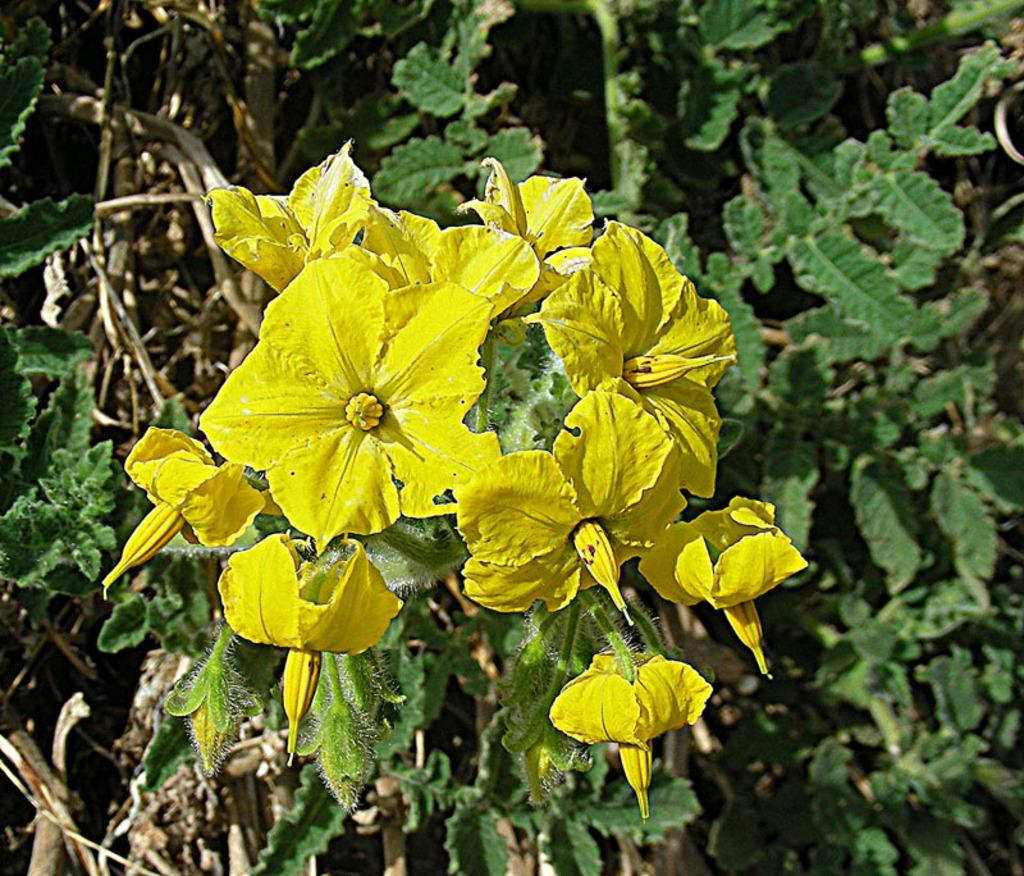What type of living organisms are in the image? There are plants in the image. What specific feature can be observed on the plants? The plants have flowers. What is the color of the flowers on the plants? The flowers are in yellow color. What story does the finger tell in the image? There is no finger present in the image, so it is not possible to determine any story it might tell. 